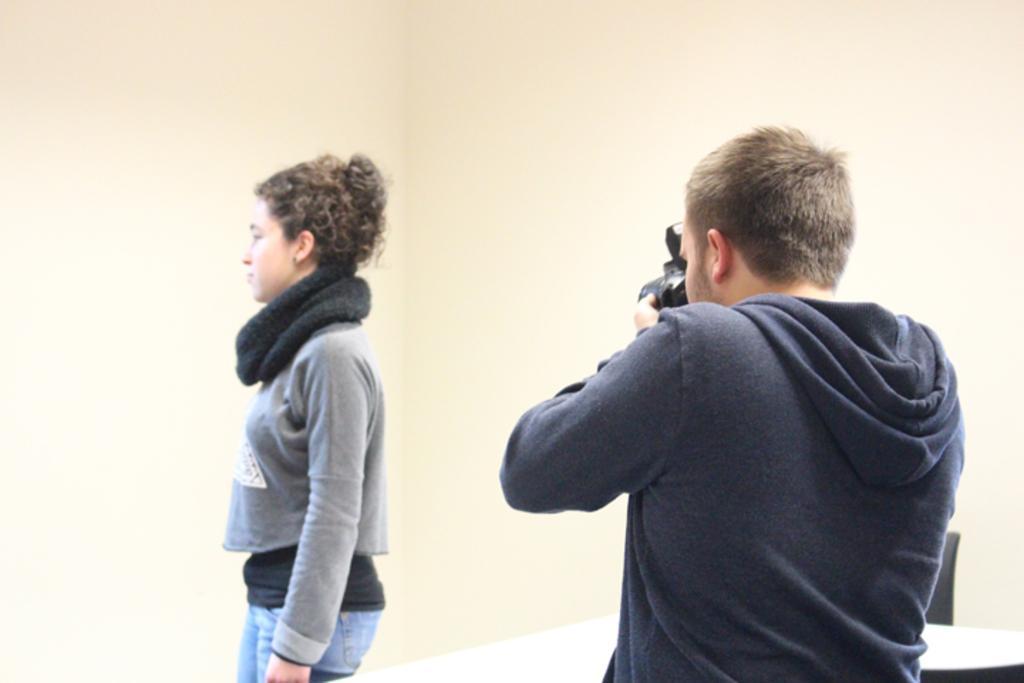Could you give a brief overview of what you see in this image? This image consists of a woman standing and wearing gray jacket. To the right, there is a man holding a camera and capturing the woman. In the background, there is a wall in cream color. 